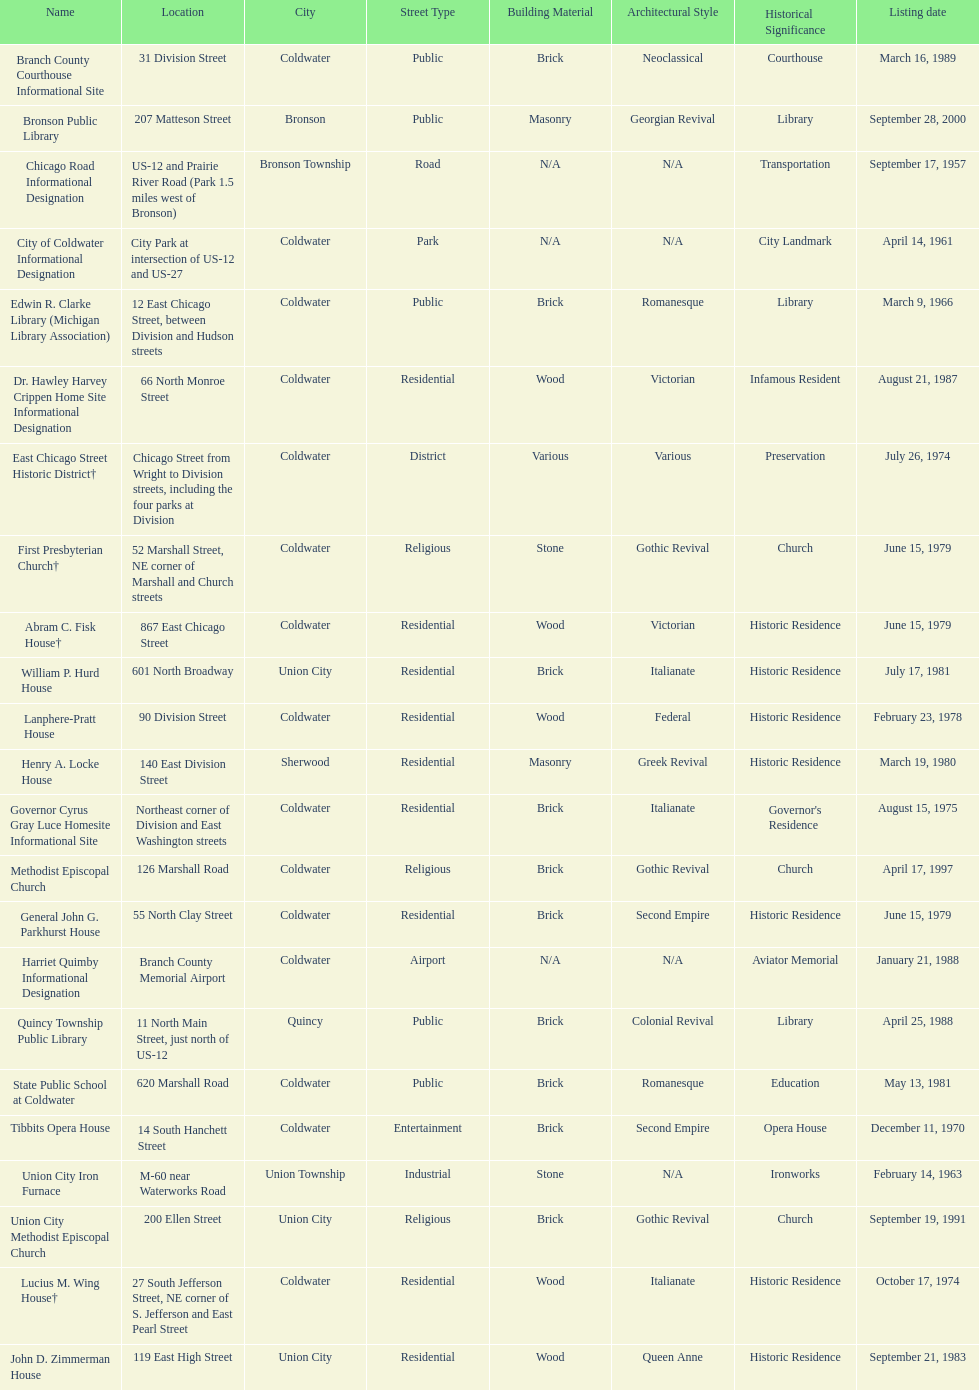How many historic sites were listed in 1988? 2. 